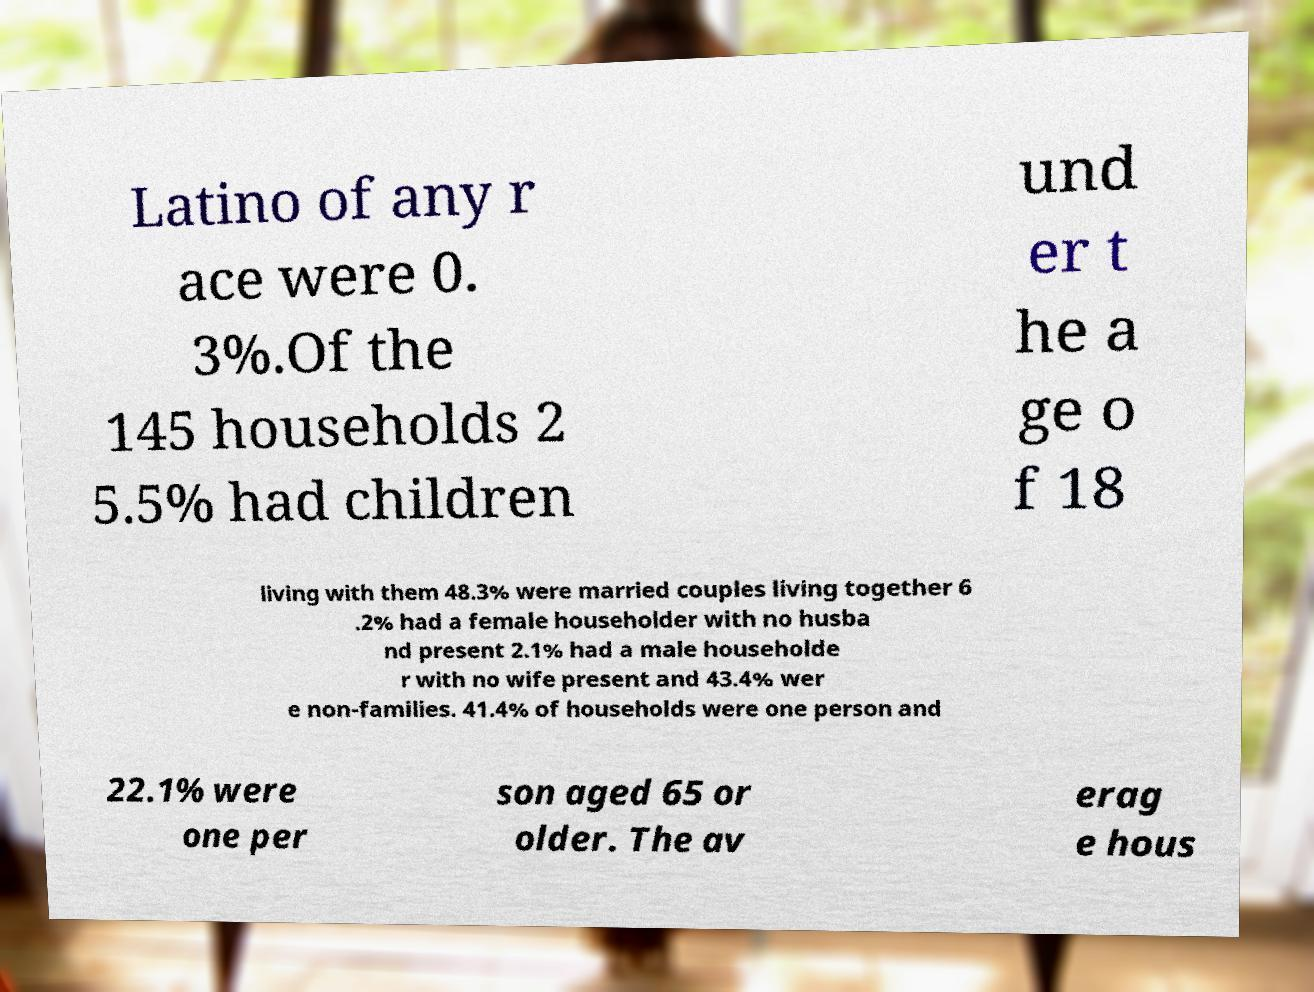I need the written content from this picture converted into text. Can you do that? Latino of any r ace were 0. 3%.Of the 145 households 2 5.5% had children und er t he a ge o f 18 living with them 48.3% were married couples living together 6 .2% had a female householder with no husba nd present 2.1% had a male householde r with no wife present and 43.4% wer e non-families. 41.4% of households were one person and 22.1% were one per son aged 65 or older. The av erag e hous 